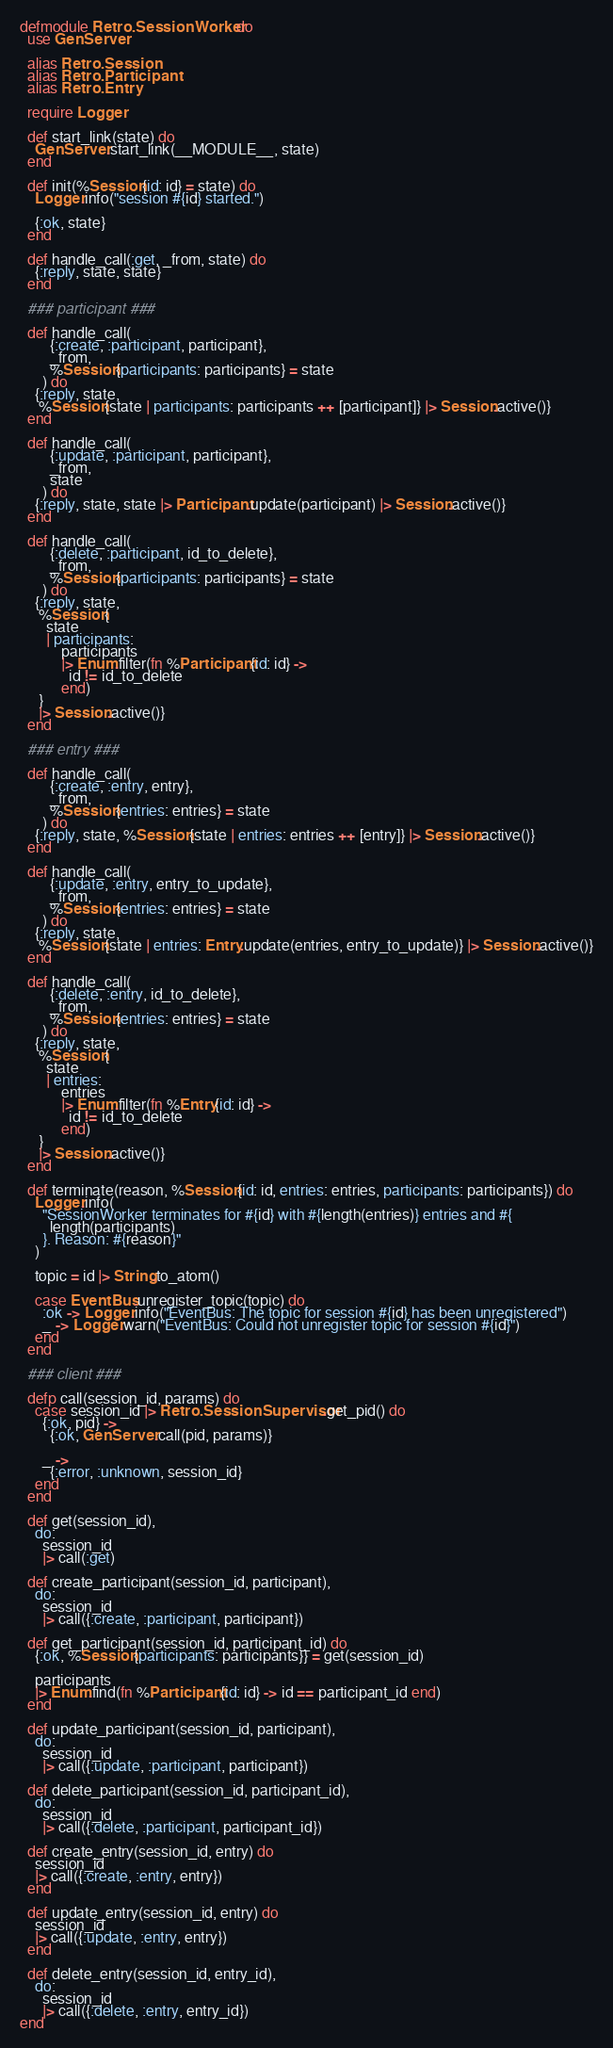<code> <loc_0><loc_0><loc_500><loc_500><_Elixir_>defmodule Retro.SessionWorker do
  use GenServer

  alias Retro.Session
  alias Retro.Participant
  alias Retro.Entry

  require Logger

  def start_link(state) do
    GenServer.start_link(__MODULE__, state)
  end

  def init(%Session{id: id} = state) do
    Logger.info("session #{id} started.")

    {:ok, state}
  end

  def handle_call(:get, _from, state) do
    {:reply, state, state}
  end

  ### participant ###

  def handle_call(
        {:create, :participant, participant},
        _from,
        %Session{participants: participants} = state
      ) do
    {:reply, state,
     %Session{state | participants: participants ++ [participant]} |> Session.active()}
  end

  def handle_call(
        {:update, :participant, participant},
        _from,
        state
      ) do
    {:reply, state, state |> Participant.update(participant) |> Session.active()}
  end

  def handle_call(
        {:delete, :participant, id_to_delete},
        _from,
        %Session{participants: participants} = state
      ) do
    {:reply, state,
     %Session{
       state
       | participants:
           participants
           |> Enum.filter(fn %Participant{id: id} ->
             id != id_to_delete
           end)
     }
     |> Session.active()}
  end

  ### entry ###

  def handle_call(
        {:create, :entry, entry},
        _from,
        %Session{entries: entries} = state
      ) do
    {:reply, state, %Session{state | entries: entries ++ [entry]} |> Session.active()}
  end

  def handle_call(
        {:update, :entry, entry_to_update},
        _from,
        %Session{entries: entries} = state
      ) do
    {:reply, state,
     %Session{state | entries: Entry.update(entries, entry_to_update)} |> Session.active()}
  end

  def handle_call(
        {:delete, :entry, id_to_delete},
        _from,
        %Session{entries: entries} = state
      ) do
    {:reply, state,
     %Session{
       state
       | entries:
           entries
           |> Enum.filter(fn %Entry{id: id} ->
             id != id_to_delete
           end)
     }
     |> Session.active()}
  end

  def terminate(reason, %Session{id: id, entries: entries, participants: participants}) do
    Logger.info(
      "SessionWorker terminates for #{id} with #{length(entries)} entries and #{
        length(participants)
      }. Reason: #{reason}"
    )

    topic = id |> String.to_atom()

    case EventBus.unregister_topic(topic) do
      :ok -> Logger.info("EventBus: The topic for session #{id} has been unregistered")
      _ -> Logger.warn("EventBus: Could not unregister topic for session #{id}")
    end
  end

  ### client ###

  defp call(session_id, params) do
    case session_id |> Retro.SessionSupervisor.get_pid() do
      {:ok, pid} ->
        {:ok, GenServer.call(pid, params)}

      _ ->
        {:error, :unknown, session_id}
    end
  end

  def get(session_id),
    do:
      session_id
      |> call(:get)

  def create_participant(session_id, participant),
    do:
      session_id
      |> call({:create, :participant, participant})

  def get_participant(session_id, participant_id) do
    {:ok, %Session{participants: participants}} = get(session_id)

    participants
    |> Enum.find(fn %Participant{id: id} -> id == participant_id end)
  end

  def update_participant(session_id, participant),
    do:
      session_id
      |> call({:update, :participant, participant})

  def delete_participant(session_id, participant_id),
    do:
      session_id
      |> call({:delete, :participant, participant_id})

  def create_entry(session_id, entry) do
    session_id
    |> call({:create, :entry, entry})
  end

  def update_entry(session_id, entry) do
    session_id
    |> call({:update, :entry, entry})
  end

  def delete_entry(session_id, entry_id),
    do:
      session_id
      |> call({:delete, :entry, entry_id})
end
</code> 